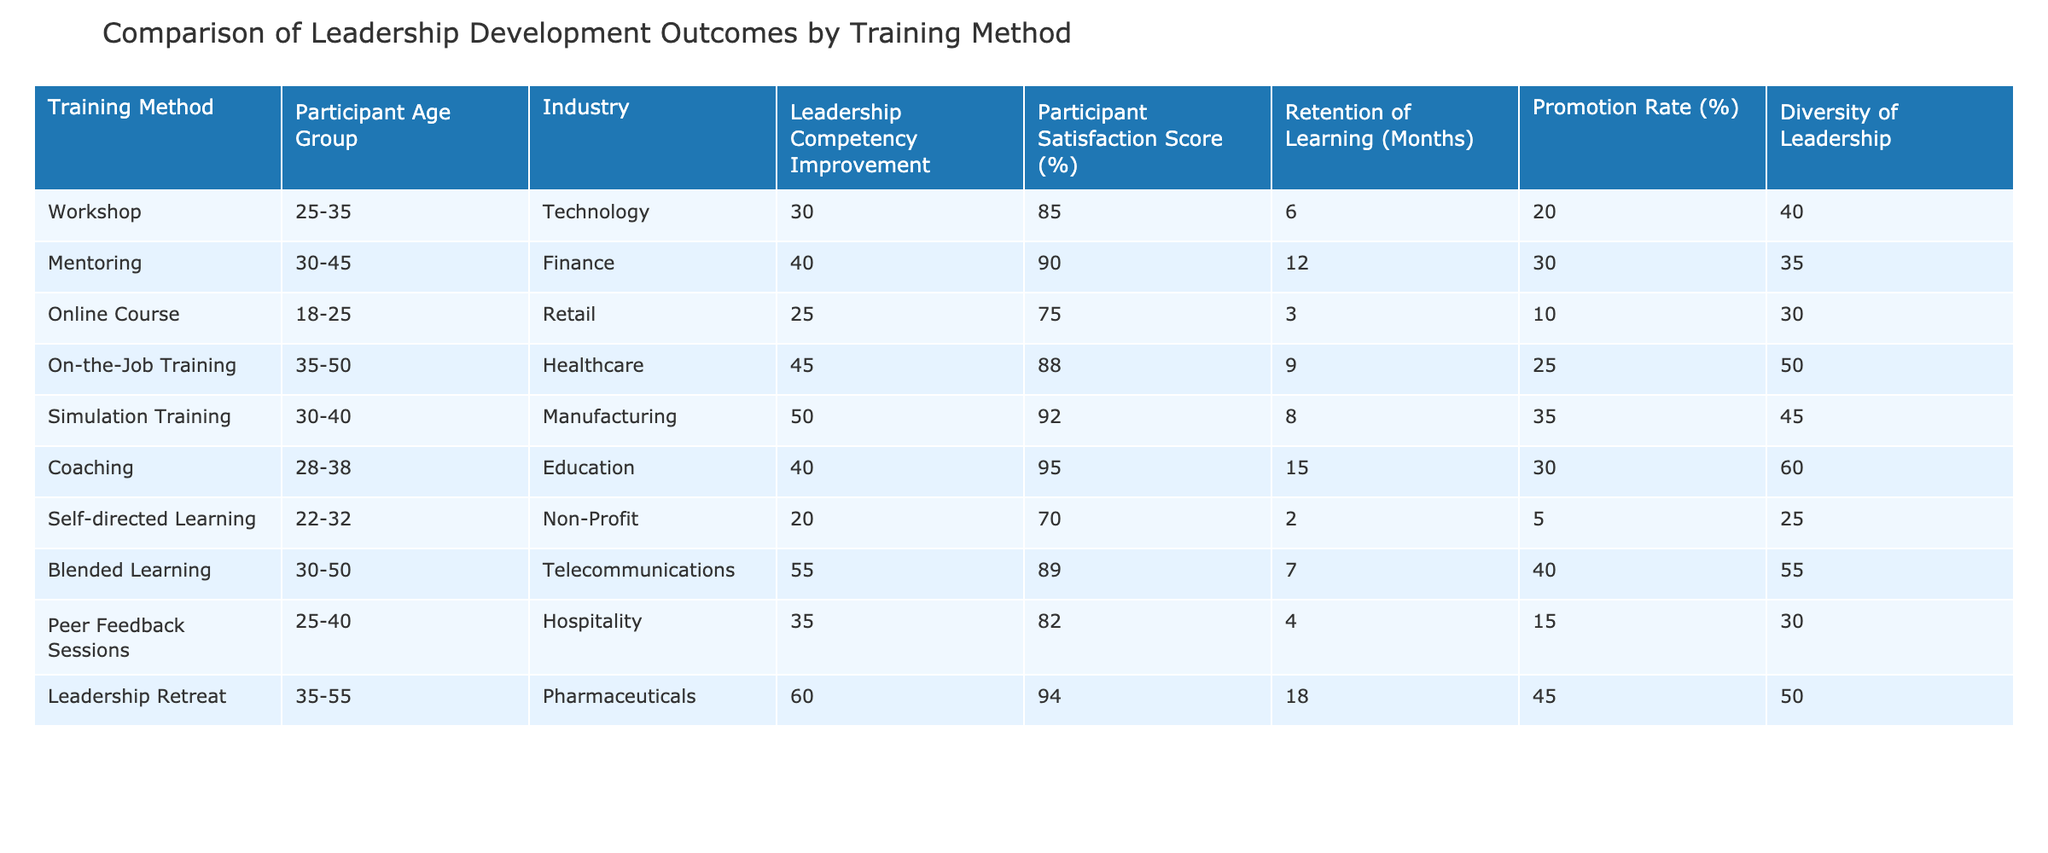What is the highest participant satisfaction score among the training methods? The highest participant satisfaction score can be found by looking at the values listed in the "Participant Satisfaction Score (%)" column. The maximum value is 95 from the Coaching method.
Answer: 95 Which training method has the lowest retention of learning? To find the lowest retention of learning, examine the "Retention of Learning (Months)" column. The minimum value is 2 from Self-directed Learning.
Answer: 2 What is the average promotion rate across all training methods? To find the average promotion rate, sum the promotion rates (20 + 30 + 10 + 25 + 35 + 30 + 5 + 40 + 15 + 45) which equals 355, then divide by the number of methods (10). The average is 355 / 10 = 35.5.
Answer: 35.5 Which training method shows the highest improvement in leadership competency? The table indicates the improvement in leadership competency in the "Leadership Competency Improvement" column. The maximum improvement is 60 from the Leadership Retreat.
Answer: 60 Is there a training method that offers a diversity of leadership below 30%? Reviewing the "Diversity of Leadership" column reveals that Self-directed Learning has a diversity of leadership of 25%, which is below 30%.
Answer: Yes What training method has both the highest competency improvement and the highest participant satisfaction score? First, look at the "Leadership Competency Improvement" and "Participant Satisfaction Score (%)" columns. Leadership Retreat scores 60 for improvement and 94 for satisfaction, which are the highest values in their respective columns.
Answer: Leadership Retreat What is the difference in retention of learning between the method with the highest score and the one with the lowest score? The highest retention of learning is 18 months (Leadership Retreat) and the lowest is 2 months (Self-directed Learning). The difference is 18 - 2 = 16 months.
Answer: 16 Which industry shows the highest diversity in leadership based on the table? Investigating the "Diversity of Leadership" column for the highest number shows that Coaching (60%) has the maximum diversity reported in the table.
Answer: Coaching How does the promotion rate of On-the-Job Training compare to that of the Online Course? The promotion rate for On-the-Job Training is 25%, while for Online Course, it is 10%. The difference is 25 - 10 = 15%, meaning On-the-Job Training has a higher promotion rate.
Answer: 15% higher Count how many training methods are provided for the age group 30-45. Counting the rows where "Participant Age Group" is 30-45, we find Mentoring, Simulation Training, and Blended Learning, totaling 3 methods.
Answer: 3 What is the relationship between age group and retention of learning, based on the maximum and minimum values observed? Comparing the retention of learning across age groups, we see that younger participants (18-25) have the lowest (3 months), while older participants (35-55) have the highest (18 months), indicating older participants retain learning longer.
Answer: Older participants retain learning longer 